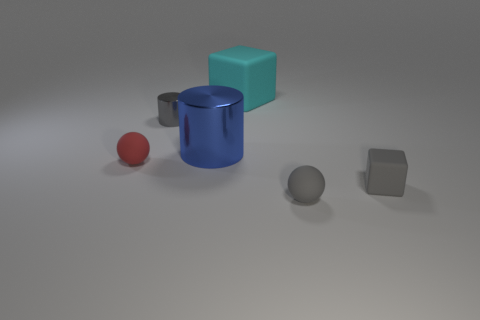What size is the metal object that is the same color as the tiny rubber block?
Offer a terse response. Small. What is the color of the ball behind the rubber cube on the right side of the big matte object?
Ensure brevity in your answer.  Red. Are there any blue metal cylinders that have the same size as the red sphere?
Your answer should be very brief. No. There is a sphere to the right of the large object on the left side of the big object that is on the right side of the blue shiny thing; what is it made of?
Offer a very short reply. Rubber. There is a small rubber ball that is in front of the tiny red sphere; how many matte cubes are to the left of it?
Provide a succinct answer. 1. There is a cube that is behind the blue metal object; is it the same size as the big blue cylinder?
Your answer should be compact. Yes. How many other cyan objects are the same shape as the cyan matte thing?
Offer a terse response. 0. What is the shape of the blue shiny object?
Offer a terse response. Cylinder. Are there an equal number of tiny gray rubber cubes behind the blue thing and green cubes?
Make the answer very short. Yes. Are there any other things that are made of the same material as the gray ball?
Ensure brevity in your answer.  Yes. 